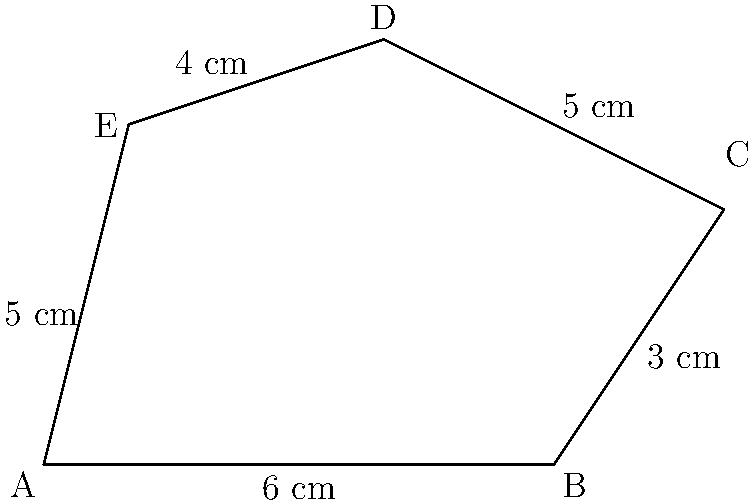As a multilingual scholar working on translating deciphered texts, you encounter a historical map with a polygonal boundary. The map's scale indicates that 1 unit on the diagram represents 1 cm in reality. Calculate the perimeter of the polygon ABCDE shown in the diagram. To calculate the perimeter of the polygon ABCDE, we need to sum up the lengths of all its sides. Let's go through this step-by-step:

1. Side AB: The length is given as 6 cm.

2. Side BC: The length is given as 3 cm.

3. Side CD: The length is given as 5 cm.

4. Side DE: The length is given as 4 cm.

5. Side EA: The length is given as 5 cm.

Now, we can calculate the perimeter by adding all these lengths:

$$\text{Perimeter} = AB + BC + CD + DE + EA$$
$$\text{Perimeter} = 6 + 3 + 5 + 4 + 5 = 23$$

Therefore, the perimeter of the polygon ABCDE is 23 cm.

This calculation method is particularly useful when working with historical maps, as it allows us to accurately measure and describe the boundaries of ancient territories or archaeological sites.
Answer: 23 cm 